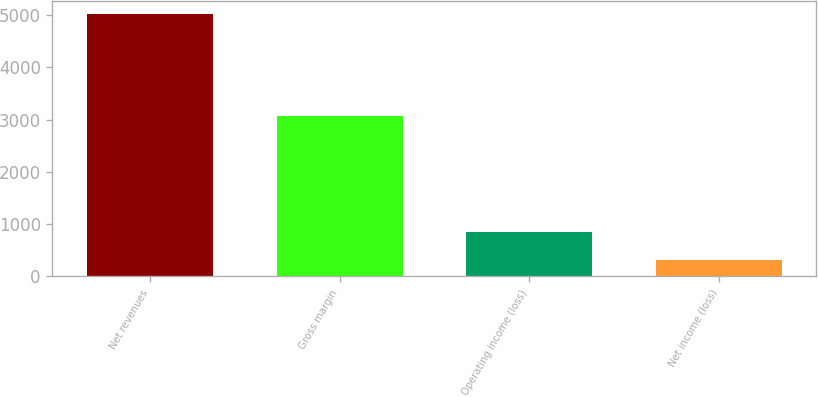Convert chart to OTSL. <chart><loc_0><loc_0><loc_500><loc_500><bar_chart><fcel>Net revenues<fcel>Gross margin<fcel>Operating income (loss)<fcel>Net income (loss)<nl><fcel>5027.2<fcel>3072.1<fcel>848.1<fcel>306.2<nl></chart> 